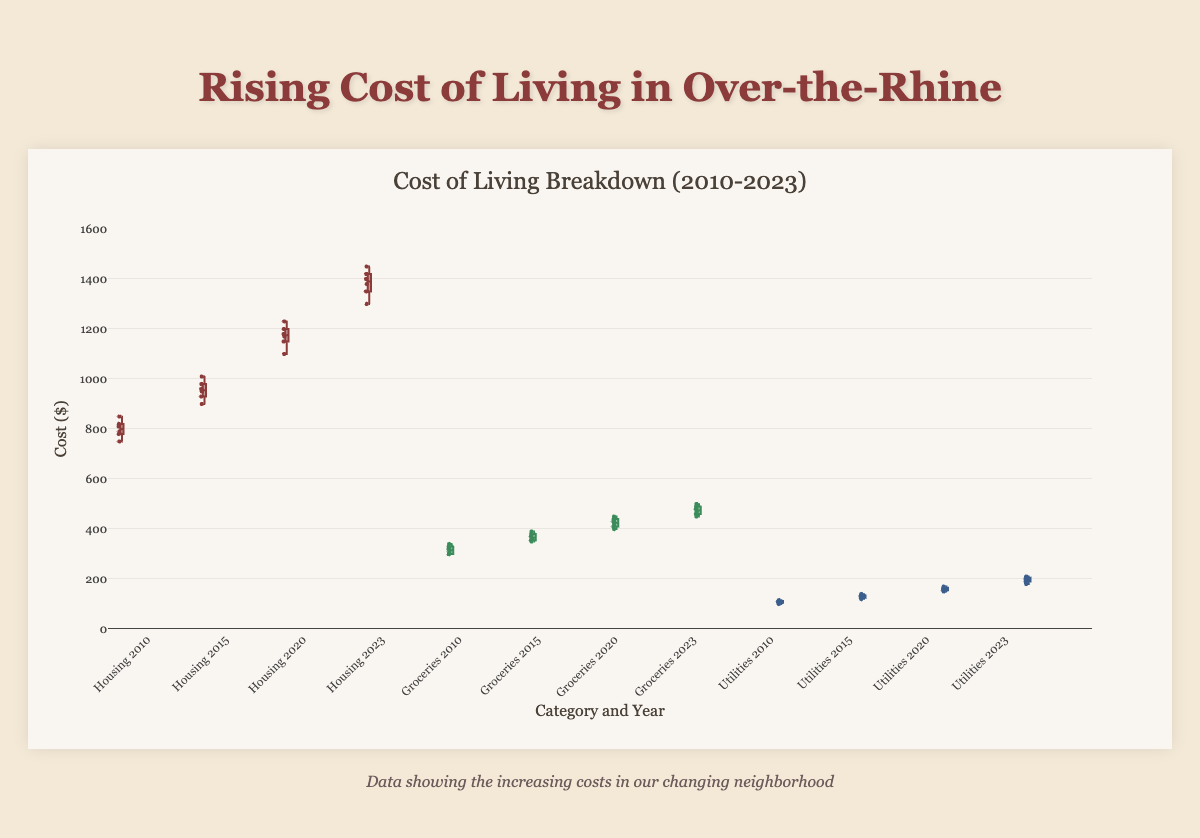What is the general trend of housing costs from 2010 to 2023? The box plot shows housing costs increasing for each successive year, with 2023 being significantly higher than 2010. This indicates a steady rise in housing costs over the years.
Answer: Increasing Which category experienced the highest cost in 2023? By visually examining the box plots for 2023, Housing has the highest costs, with data points well above those for Groceries and Utilities.
Answer: Housing How does the range of grocery costs in 2023 compare to that in 2010? The range for groceries costs can be found by considering the spread of the box plots. In 2023, the grocery costs range from 450 to 500, while in 2010, they range from 300 to 340, indicating that the range of grocery costs increased over time.
Answer: Increased What is the median cost for utilities in 2020? Median is the middle value of the sorted data points in the box. For Utilities in 2020, the median line within the box is at around 160.
Answer: 160 How much did the average housing cost increase from 2010 to 2015? For 2010, the average housing cost is (750+780+810+790+820+850)/6 = 800. For 2015, the average is (900+930+960+950+980+1010)/6 = 955. Therefore, the increase is 955 - 800 = 155.
Answer: 155 Between 2010 and 2023, which category had the smallest change in cost? Comparison of the minimum and maximum values of the boxes for each year shows the smallest difference for Utilities. Utilities had the least increase compared to Housing and Groceries.
Answer: Utilities Which year shows the widest range of costs for housing? The range is determined by the distance between the lowest and highest values in the box plot. For housing, 2023 shows the widest range, from 1300 to 1450.
Answer: 2023 Considering all categories, which year shows the generally lowest overall costs? By looking at the overall height of the boxes in each year, 2010 shows generally lower overall costs compared to 2015, 2020, and 2023.
Answer: 2010 